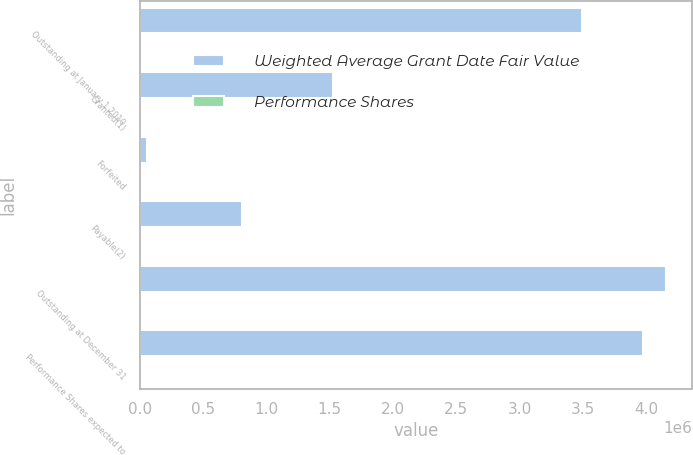Convert chart. <chart><loc_0><loc_0><loc_500><loc_500><stacked_bar_chart><ecel><fcel>Outstanding at January 1 2010<fcel>Granted(1)<fcel>Forfeited<fcel>Payable(2)<fcel>Outstanding at December 31<fcel>Performance Shares expected to<nl><fcel>Weighted Average Grant Date Fair Value<fcel>3.49344e+06<fcel>1.52806e+06<fcel>58176<fcel>807750<fcel>4.15557e+06<fcel>3.97277e+06<nl><fcel>Performance Shares<fcel>38.43<fcel>32.24<fcel>30.06<fcel>60.83<fcel>31.91<fcel>33.4<nl></chart> 